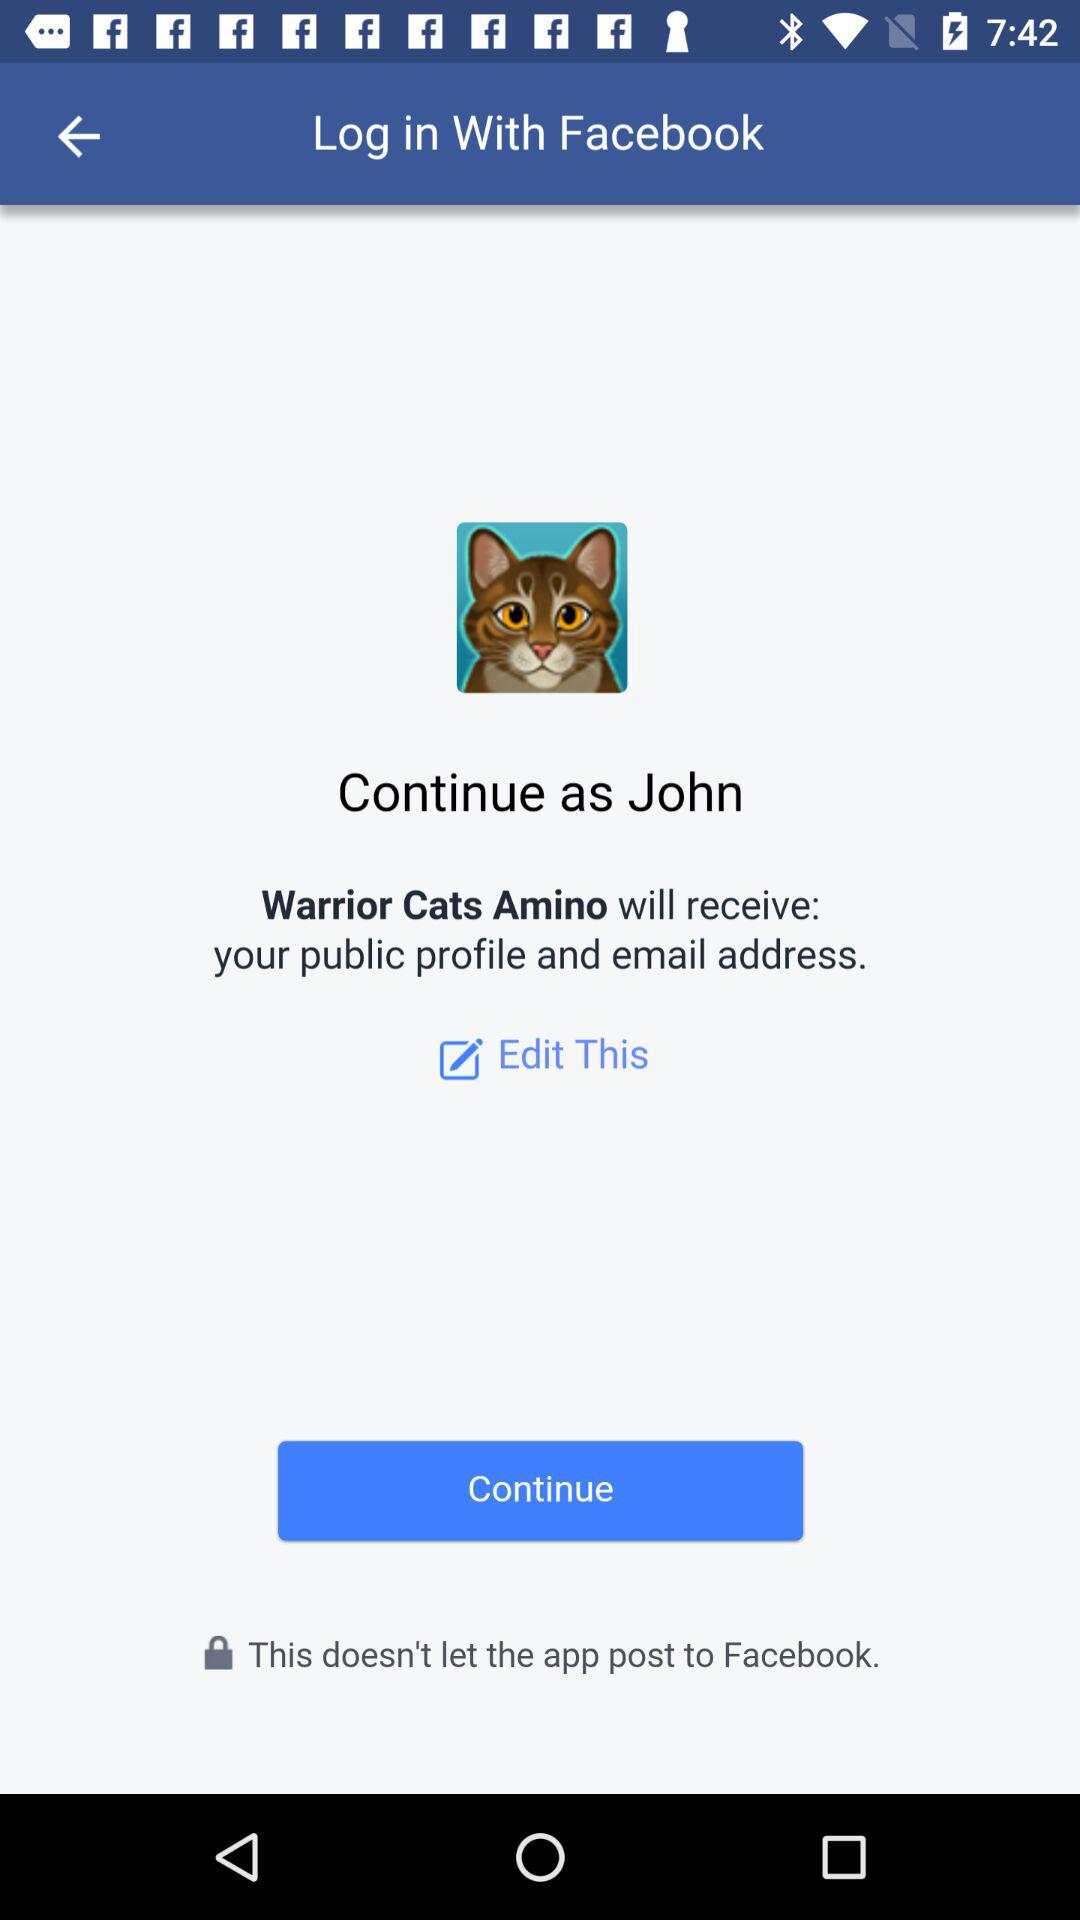What is the name of the user? The user name is "John". 